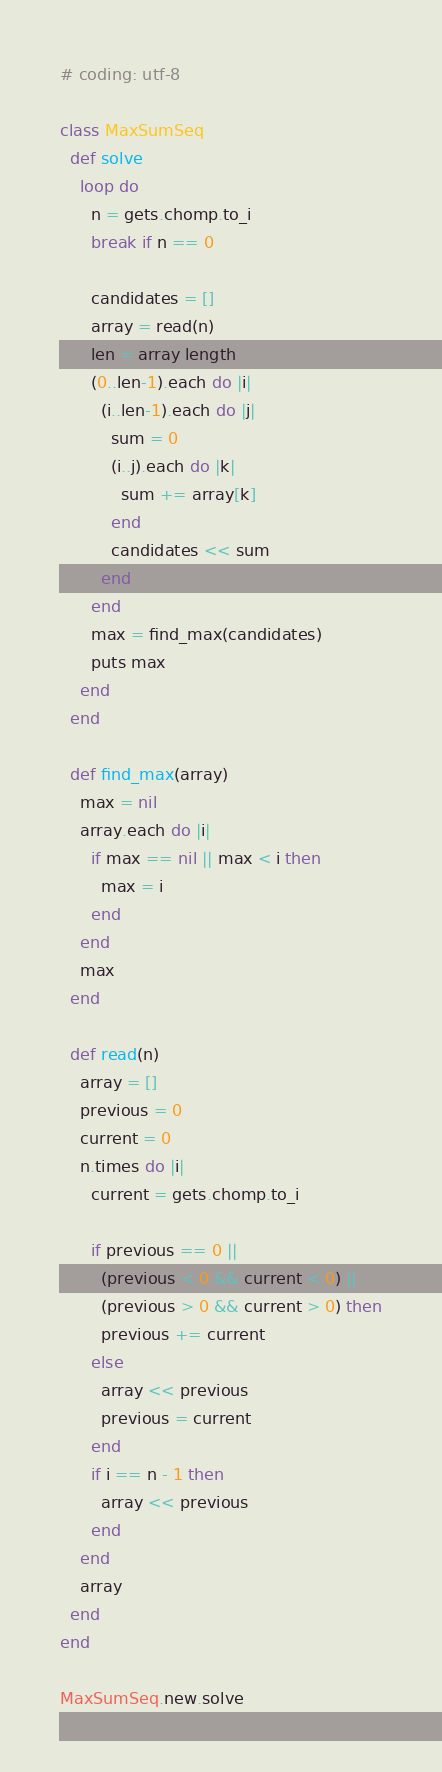Convert code to text. <code><loc_0><loc_0><loc_500><loc_500><_Ruby_># coding: utf-8

class MaxSumSeq
  def solve
    loop do
      n = gets.chomp.to_i
      break if n == 0

      candidates = []
      array = read(n)
      len = array.length
      (0..len-1).each do |i|
        (i..len-1).each do |j|
          sum = 0
          (i..j).each do |k|
            sum += array[k]
          end
          candidates << sum
        end
      end
      max = find_max(candidates)
      puts max
    end
  end

  def find_max(array)
    max = nil
    array.each do |i|
      if max == nil || max < i then
        max = i
      end
    end
    max
  end

  def read(n)
    array = []
    previous = 0
    current = 0
    n.times do |i|
      current = gets.chomp.to_i

      if previous == 0 ||
        (previous < 0 && current < 0) ||
        (previous > 0 && current > 0) then
        previous += current
      else
        array << previous
        previous = current
      end
      if i == n - 1 then
        array << previous
      end
    end
    array
  end
end

MaxSumSeq.new.solve</code> 